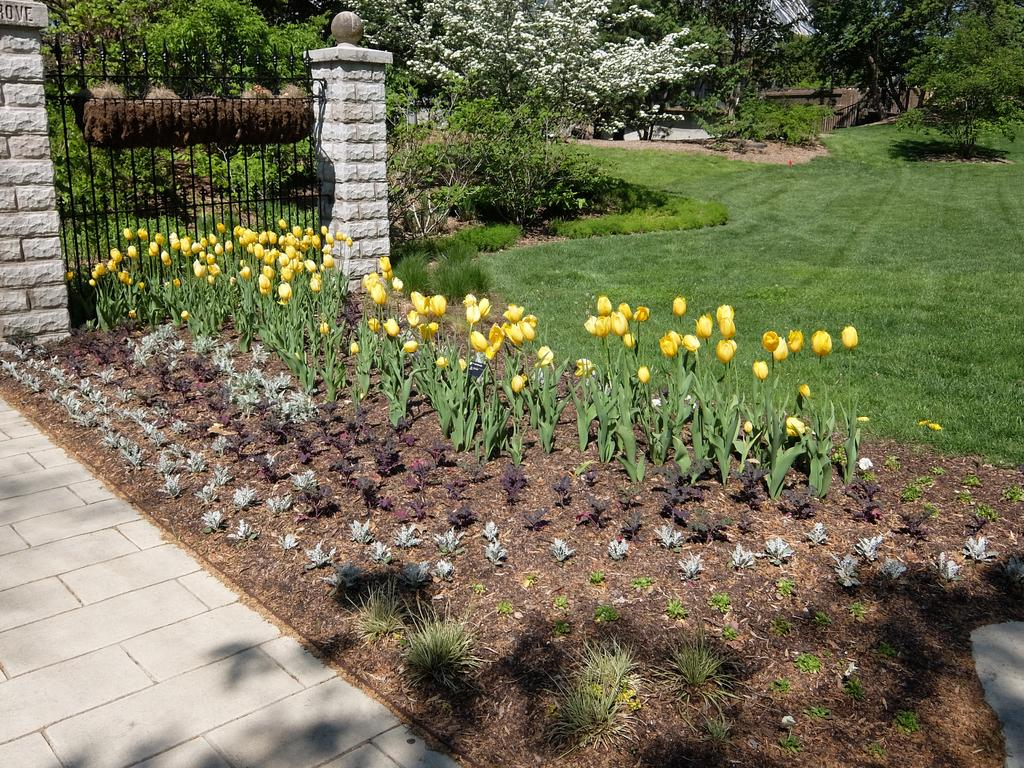What type of vegetation covers the land in the image? The land in the image is covered with flower plants, grass, and trees. Can you describe the fence in the image? There is a fence on the left side of the image. What type of lamp is hanging from the tree in the image? There is no lamp present in the image; it features land covered with vegetation and a fence on the left side. 